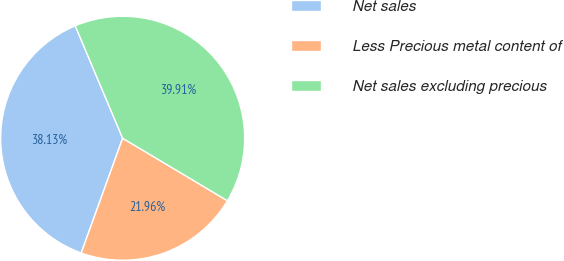<chart> <loc_0><loc_0><loc_500><loc_500><pie_chart><fcel>Net sales<fcel>Less Precious metal content of<fcel>Net sales excluding precious<nl><fcel>38.13%<fcel>21.96%<fcel>39.91%<nl></chart> 